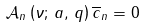Convert formula to latex. <formula><loc_0><loc_0><loc_500><loc_500>\mathcal { A } _ { n } \left ( \nu ; \, a , \, q \right ) \overline { c } _ { n } = 0</formula> 